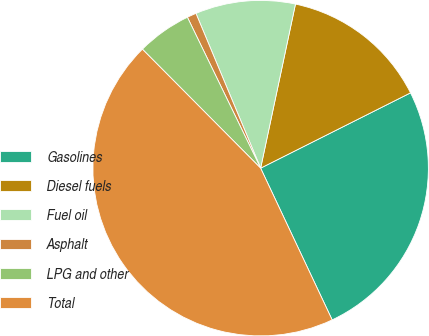Convert chart to OTSL. <chart><loc_0><loc_0><loc_500><loc_500><pie_chart><fcel>Gasolines<fcel>Diesel fuels<fcel>Fuel oil<fcel>Asphalt<fcel>LPG and other<fcel>Total<nl><fcel>25.4%<fcel>14.26%<fcel>9.63%<fcel>0.89%<fcel>5.26%<fcel>44.56%<nl></chart> 